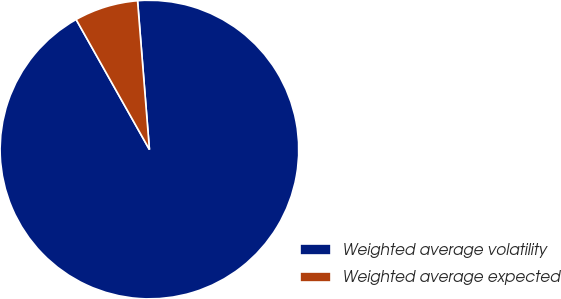<chart> <loc_0><loc_0><loc_500><loc_500><pie_chart><fcel>Weighted average volatility<fcel>Weighted average expected<nl><fcel>93.1%<fcel>6.9%<nl></chart> 